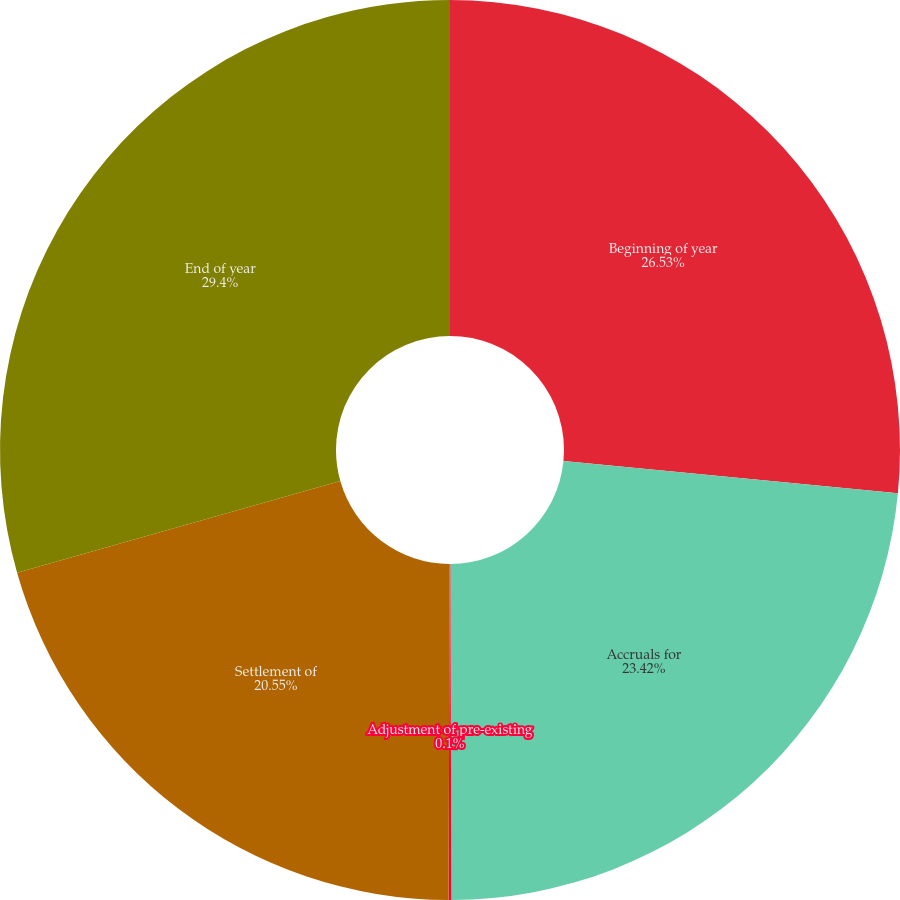Convert chart. <chart><loc_0><loc_0><loc_500><loc_500><pie_chart><fcel>Beginning of year<fcel>Accruals for<fcel>Adjustment of pre-existing<fcel>Settlement of<fcel>End of year<nl><fcel>26.53%<fcel>23.42%<fcel>0.1%<fcel>20.55%<fcel>29.4%<nl></chart> 